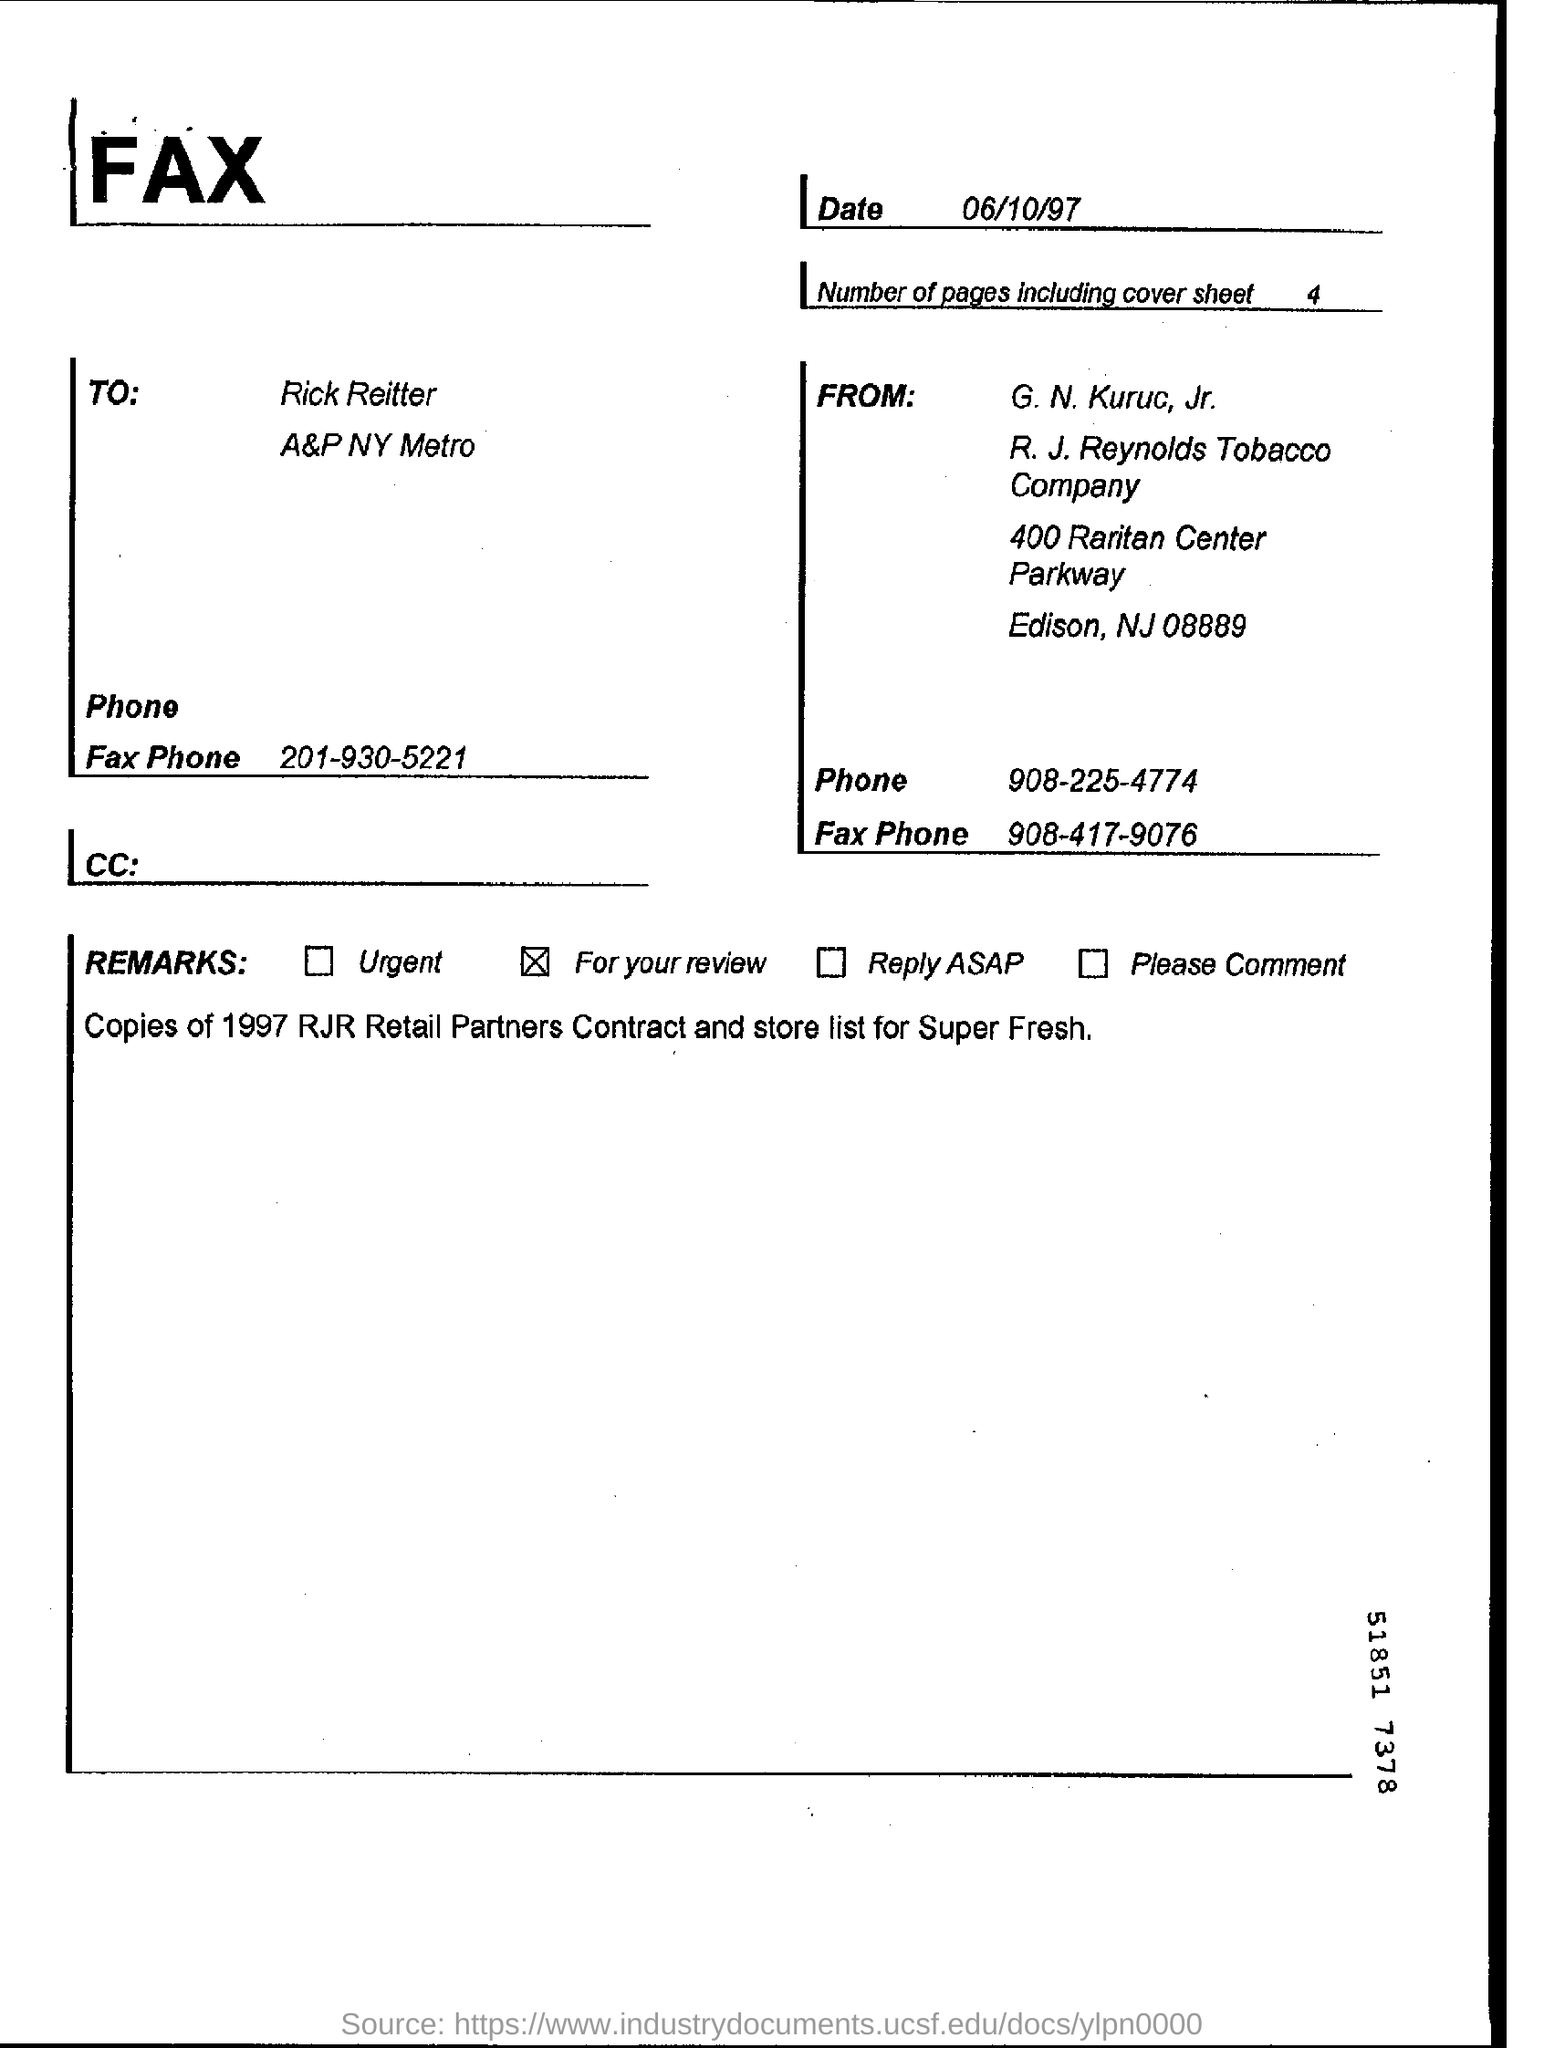Mention the date when the fax was sent?
Ensure brevity in your answer.  06/10/97. Name the person to whom the fax was sent?
Your response must be concise. Rick Reitter. What is the REMARK ticked?
Ensure brevity in your answer.  For your review. Name the person who sent the fax?
Offer a very short reply. G. N. Kuruc, Jr. 